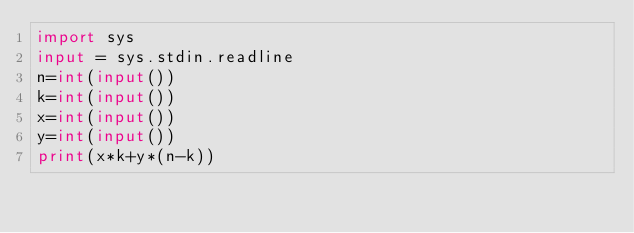Convert code to text. <code><loc_0><loc_0><loc_500><loc_500><_Python_>import sys
input = sys.stdin.readline
n=int(input())
k=int(input())
x=int(input())
y=int(input())
print(x*k+y*(n-k))
</code> 